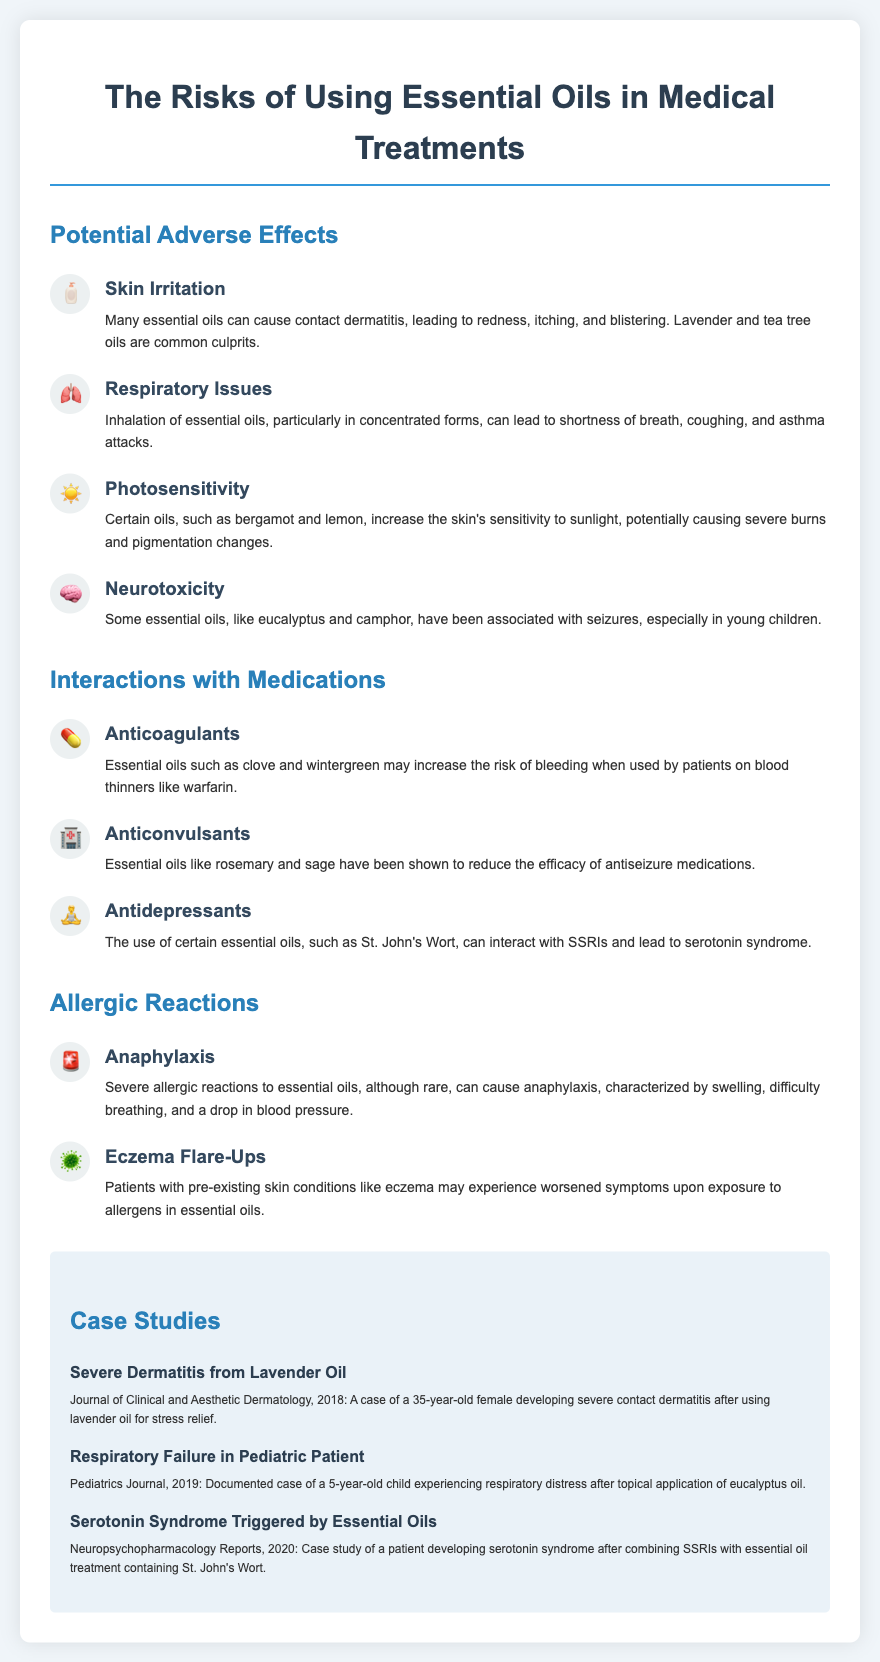What are the potential adverse effects listed? The document lists several potential adverse effects under the "Potential Adverse Effects" section, including skin irritation, respiratory issues, photosensitivity, and neurotoxicity.
Answer: skin irritation, respiratory issues, photosensitivity, neurotoxicity Which essential oil is associated with severe dermatitis in the case study? The case study mentions lavender oil as the cause of severe contact dermatitis in a 35-year-old female.
Answer: lavender oil What medication interaction is specifically noted with anticoagulants? The document states that essential oils such as clove and wintergreen may increase the risk of bleeding with blood thinners like warfarin.
Answer: clove, wintergreen How many case studies are mentioned in the document? The document lists three specific case studies related to adverse effects of essential oils.
Answer: three What essential oil can cause anaphylaxis? The document states that severe allergic reactions, although rare, can occur with essential oils leading to anaphylaxis, but it does not specify a particular oil.
Answer: not specified Which essential oil can lead to serotonin syndrome when combined with SSRIs? The document specifies St. John's Wort as the essential oil that can interact with SSRIs and lead to serotonin syndrome.
Answer: St. John's Wort What section discusses respiratory issues? The section titled "Potential Adverse Effects" includes respiratory issues as a potential risk of using essential oils, particularly in concentrated forms.
Answer: Potential Adverse Effects What is the duration of the document? The document is structured as a flyer, which typically features concise and segmented information rather than a specified duration.
Answer: not applicable 